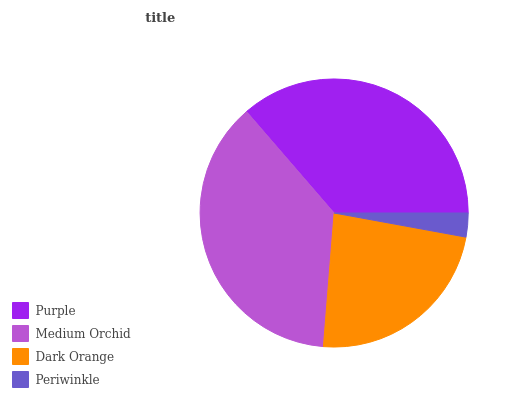Is Periwinkle the minimum?
Answer yes or no. Yes. Is Medium Orchid the maximum?
Answer yes or no. Yes. Is Dark Orange the minimum?
Answer yes or no. No. Is Dark Orange the maximum?
Answer yes or no. No. Is Medium Orchid greater than Dark Orange?
Answer yes or no. Yes. Is Dark Orange less than Medium Orchid?
Answer yes or no. Yes. Is Dark Orange greater than Medium Orchid?
Answer yes or no. No. Is Medium Orchid less than Dark Orange?
Answer yes or no. No. Is Purple the high median?
Answer yes or no. Yes. Is Dark Orange the low median?
Answer yes or no. Yes. Is Dark Orange the high median?
Answer yes or no. No. Is Purple the low median?
Answer yes or no. No. 